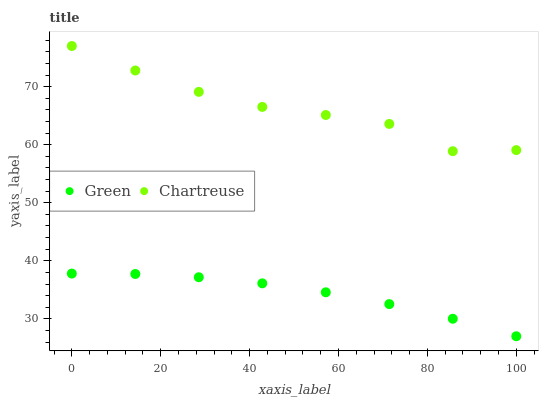Does Green have the minimum area under the curve?
Answer yes or no. Yes. Does Chartreuse have the maximum area under the curve?
Answer yes or no. Yes. Does Green have the maximum area under the curve?
Answer yes or no. No. Is Green the smoothest?
Answer yes or no. Yes. Is Chartreuse the roughest?
Answer yes or no. Yes. Is Green the roughest?
Answer yes or no. No. Does Green have the lowest value?
Answer yes or no. Yes. Does Chartreuse have the highest value?
Answer yes or no. Yes. Does Green have the highest value?
Answer yes or no. No. Is Green less than Chartreuse?
Answer yes or no. Yes. Is Chartreuse greater than Green?
Answer yes or no. Yes. Does Green intersect Chartreuse?
Answer yes or no. No. 